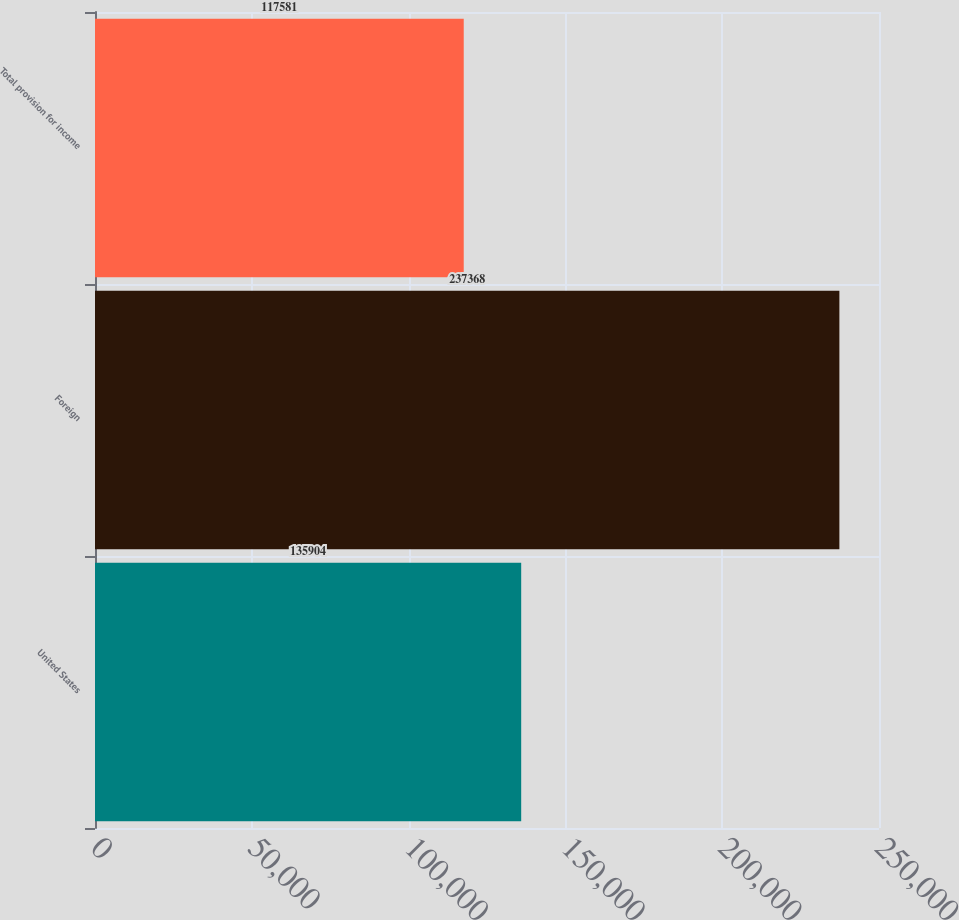Convert chart to OTSL. <chart><loc_0><loc_0><loc_500><loc_500><bar_chart><fcel>United States<fcel>Foreign<fcel>Total provision for income<nl><fcel>135904<fcel>237368<fcel>117581<nl></chart> 